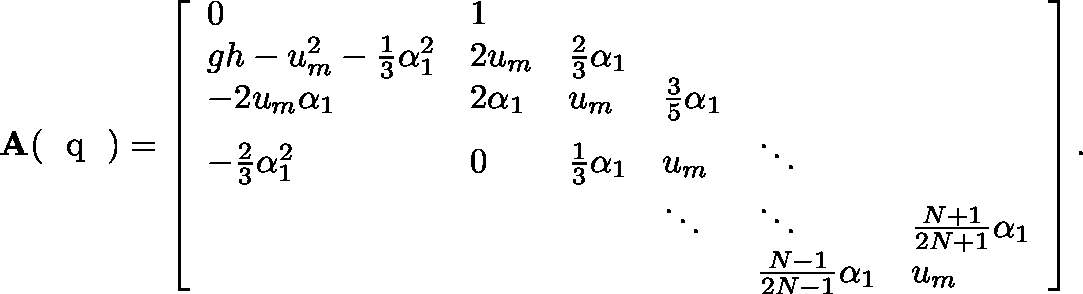Convert formula to latex. <formula><loc_0><loc_0><loc_500><loc_500>A ( q ) = \left [ \begin{array} { l l l l l l } { 0 } & { 1 } & & & & \\ { g h - u _ { m } ^ { 2 } - \frac { 1 } { 3 } \alpha _ { 1 } ^ { 2 } } & { 2 u _ { m } } & { \frac { 2 } { 3 } \alpha _ { 1 } } & & & \\ { - 2 u _ { m } \alpha _ { 1 } } & { 2 \alpha _ { 1 } } & { u _ { m } } & { \frac { 3 } { 5 } \alpha _ { 1 } } & & \\ { - \frac { 2 } { 3 } \alpha _ { 1 } ^ { 2 } } & { 0 } & { \frac { 1 } { 3 } \alpha _ { 1 } } & { u _ { m } } & { \ddots } & \\ & & & { \ddots } & { \ddots } & { \frac { N + 1 } { 2 N + 1 } \alpha _ { 1 } } \\ & & & & { \frac { N - 1 } { 2 N - 1 } \alpha _ { 1 } } & { u _ { m } } \end{array} \right ] .</formula> 